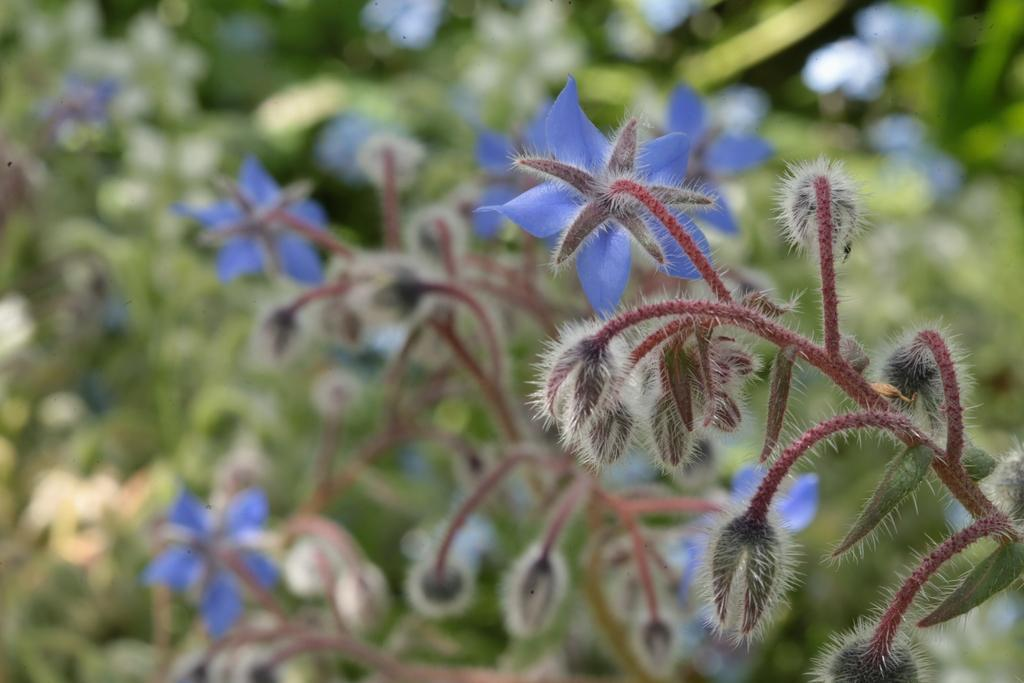What is the main subject in the foreground of the image? There is a purple flower in the foreground of the image. What is the relationship between the flower and the plant? The flower is part of a plant. What is the growth stage of the other flowers on the plant? There are buds on the plant, indicating that they are not yet fully bloomed. What can be seen in the background of the image? There are plants visible in the background of the image. What type of print can be seen on the patch of the apparel in the image? There is no apparel or print visible in the image; it features a purple flower and other plants. 